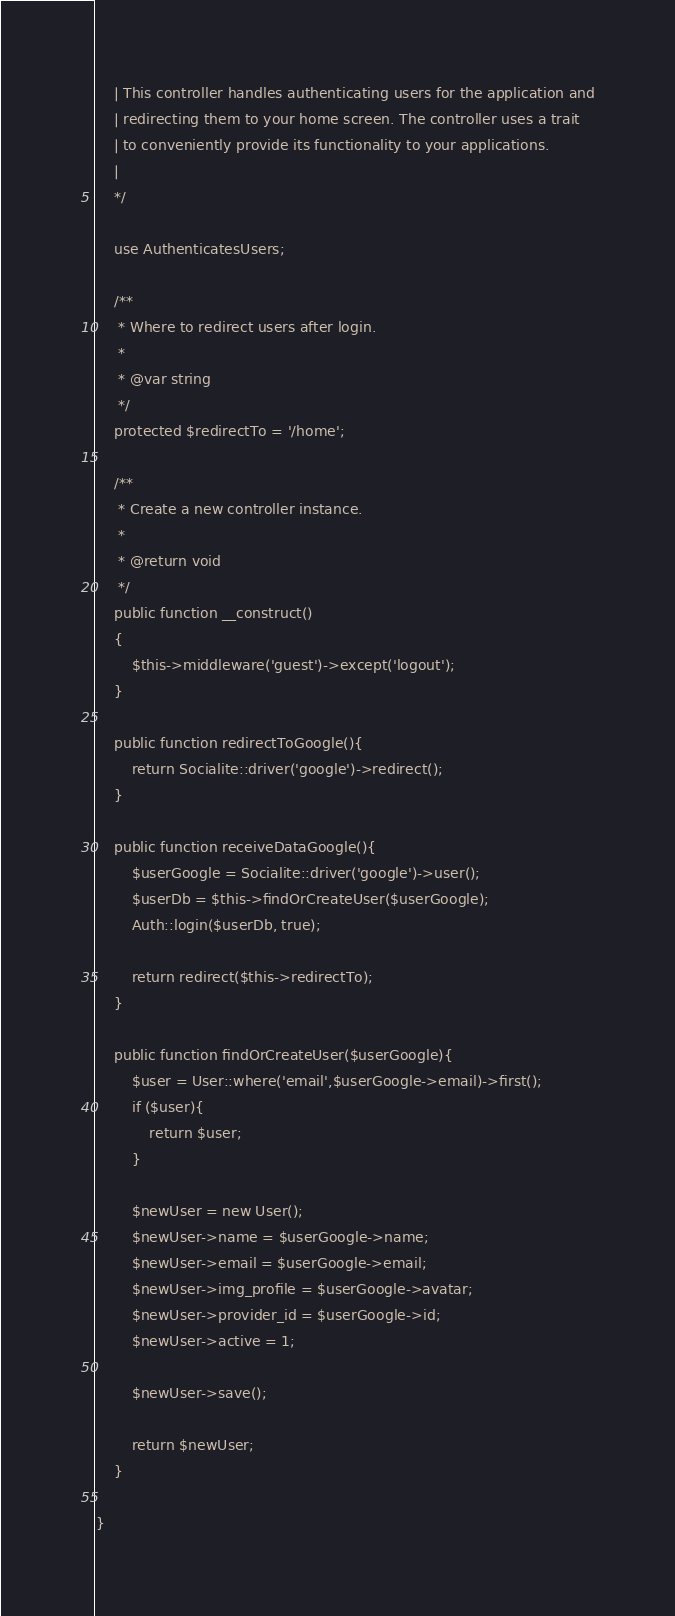<code> <loc_0><loc_0><loc_500><loc_500><_PHP_>    | This controller handles authenticating users for the application and
    | redirecting them to your home screen. The controller uses a trait
    | to conveniently provide its functionality to your applications.
    |
    */

    use AuthenticatesUsers;

    /**
     * Where to redirect users after login.
     *
     * @var string
     */
    protected $redirectTo = '/home';

    /**
     * Create a new controller instance.
     *
     * @return void
     */
    public function __construct()
    {
        $this->middleware('guest')->except('logout');
    }

    public function redirectToGoogle(){
        return Socialite::driver('google')->redirect();
    }

    public function receiveDataGoogle(){
        $userGoogle = Socialite::driver('google')->user();
        $userDb = $this->findOrCreateUser($userGoogle);
        Auth::login($userDb, true);

        return redirect($this->redirectTo);
    }

    public function findOrCreateUser($userGoogle){
        $user = User::where('email',$userGoogle->email)->first();
        if ($user){
            return $user;
        } 

        $newUser = new User();
        $newUser->name = $userGoogle->name;
        $newUser->email = $userGoogle->email;
        $newUser->img_profile = $userGoogle->avatar;
        $newUser->provider_id = $userGoogle->id;
        $newUser->active = 1;

        $newUser->save();

        return $newUser;
    }

}
</code> 